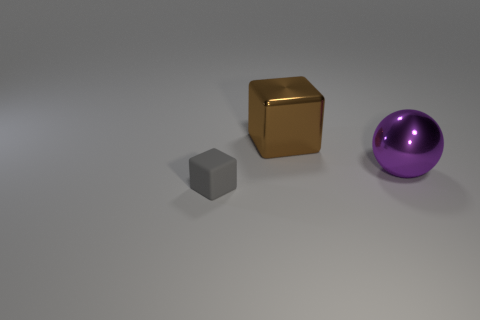Add 3 big green balls. How many objects exist? 6 Subtract all balls. How many objects are left? 2 Add 1 large purple metal objects. How many large purple metal objects are left? 2 Add 2 big cubes. How many big cubes exist? 3 Subtract 0 blue spheres. How many objects are left? 3 Subtract all large metallic cubes. Subtract all small matte blocks. How many objects are left? 1 